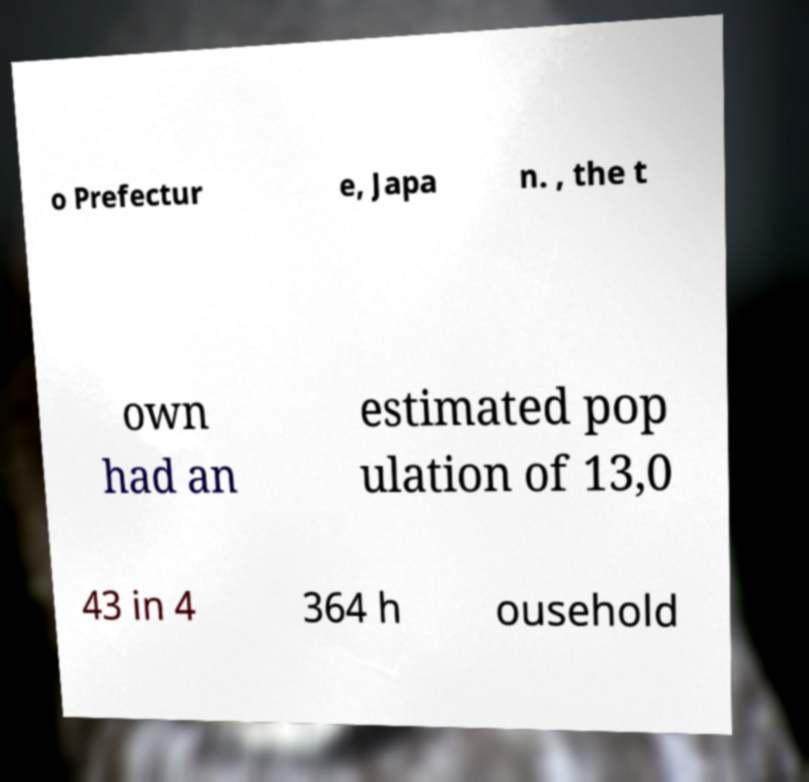Could you extract and type out the text from this image? o Prefectur e, Japa n. , the t own had an estimated pop ulation of 13,0 43 in 4 364 h ousehold 